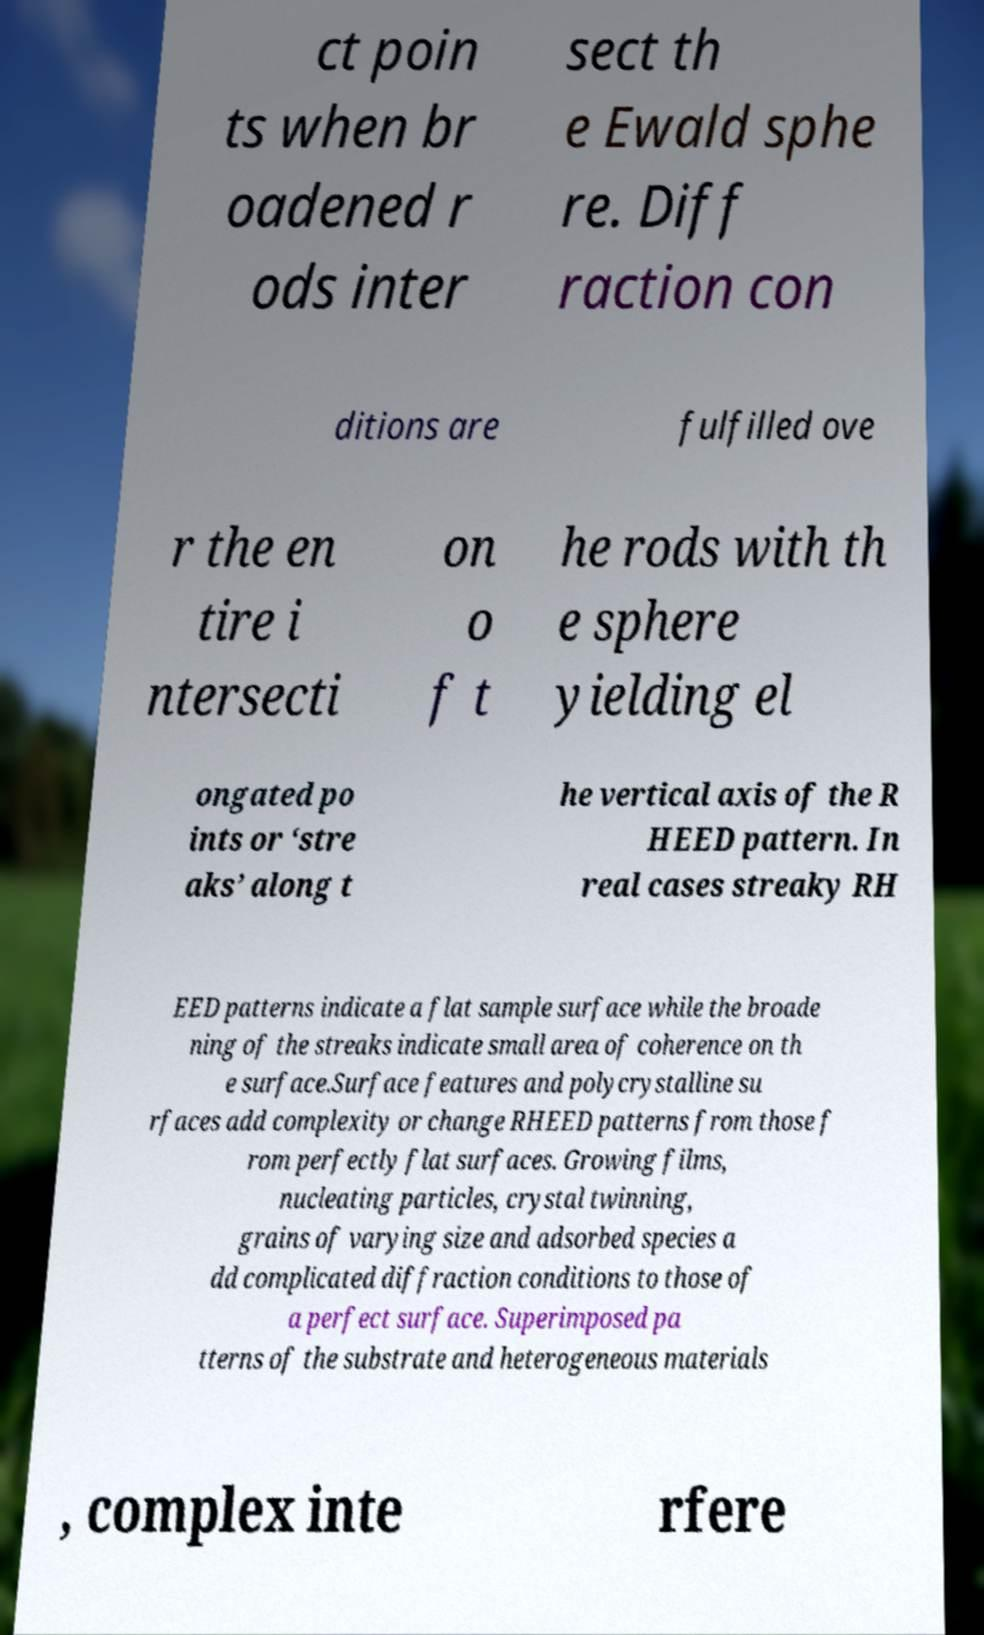I need the written content from this picture converted into text. Can you do that? ct poin ts when br oadened r ods inter sect th e Ewald sphe re. Diff raction con ditions are fulfilled ove r the en tire i ntersecti on o f t he rods with th e sphere yielding el ongated po ints or ‘stre aks’ along t he vertical axis of the R HEED pattern. In real cases streaky RH EED patterns indicate a flat sample surface while the broade ning of the streaks indicate small area of coherence on th e surface.Surface features and polycrystalline su rfaces add complexity or change RHEED patterns from those f rom perfectly flat surfaces. Growing films, nucleating particles, crystal twinning, grains of varying size and adsorbed species a dd complicated diffraction conditions to those of a perfect surface. Superimposed pa tterns of the substrate and heterogeneous materials , complex inte rfere 